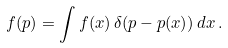<formula> <loc_0><loc_0><loc_500><loc_500>f ( p ) = \int f ( x ) \, \delta ( p - p ( x ) ) \, d x \, .</formula> 